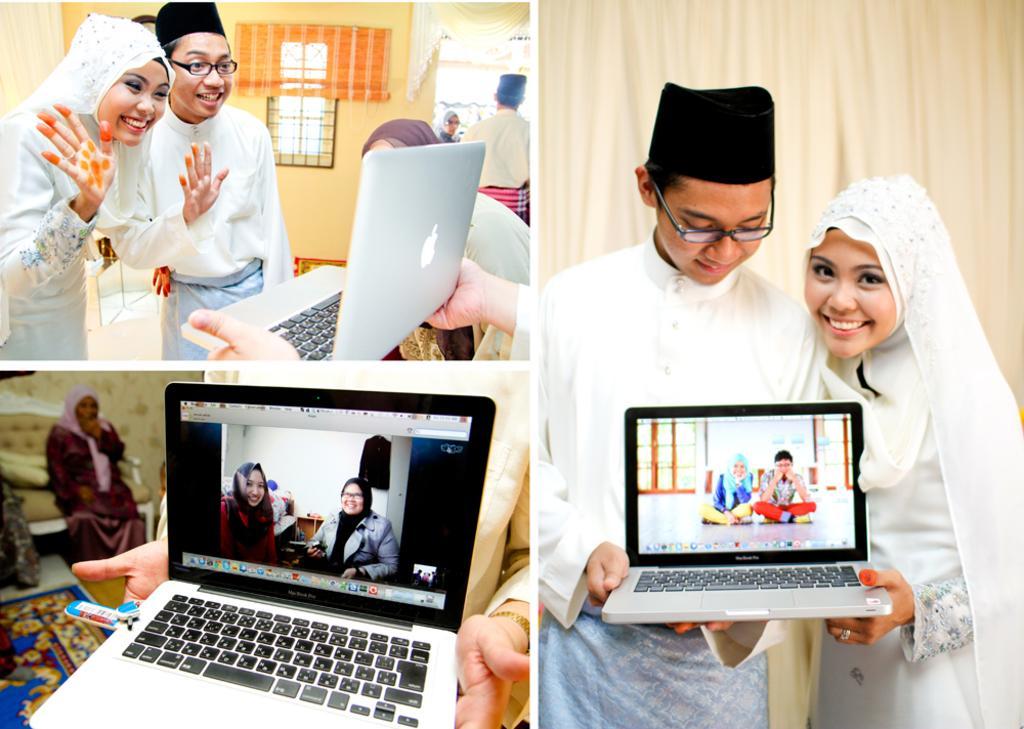How would you summarize this image in a sentence or two? This is a collage picture. I can see group of people, there is a man and a woman standing and smiling, there is a person holding a laptop, there are photos on the screen of a laptop, there is a couch, there are pillows, curtains and a window. 